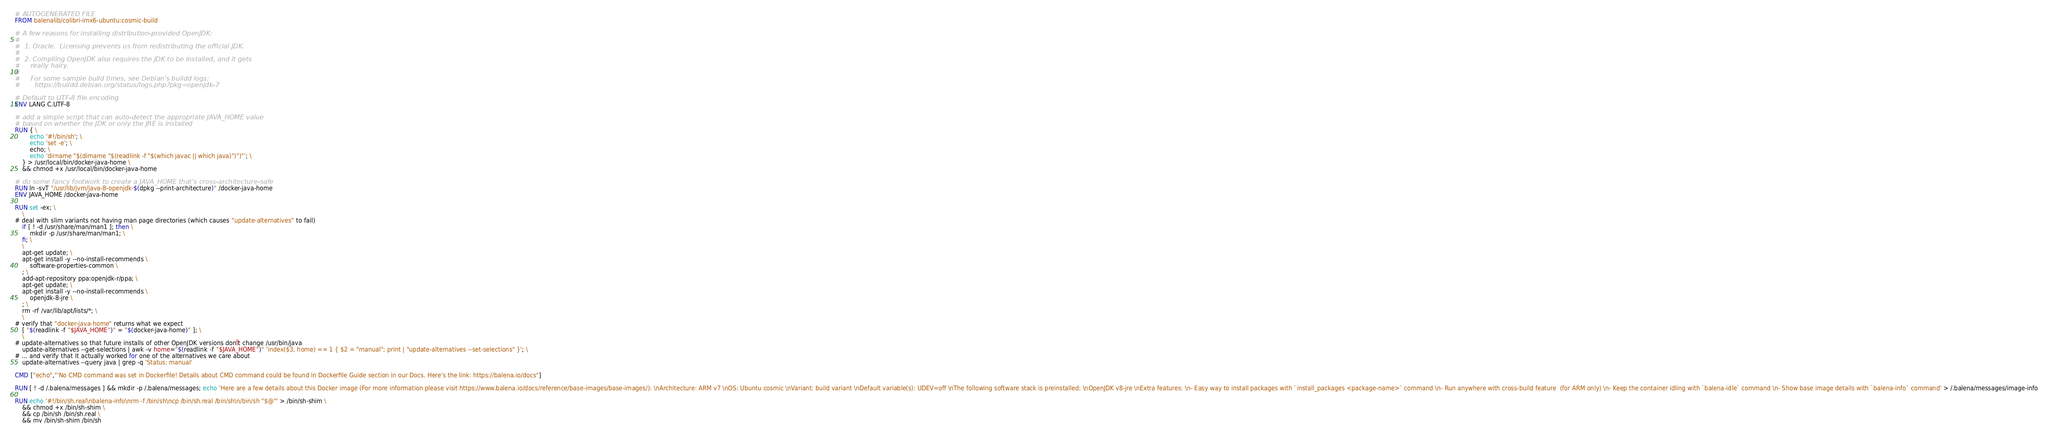<code> <loc_0><loc_0><loc_500><loc_500><_Dockerfile_># AUTOGENERATED FILE
FROM balenalib/colibri-imx6-ubuntu:cosmic-build

# A few reasons for installing distribution-provided OpenJDK:
#
#  1. Oracle.  Licensing prevents us from redistributing the official JDK.
#
#  2. Compiling OpenJDK also requires the JDK to be installed, and it gets
#     really hairy.
#
#     For some sample build times, see Debian's buildd logs:
#       https://buildd.debian.org/status/logs.php?pkg=openjdk-7

# Default to UTF-8 file.encoding
ENV LANG C.UTF-8

# add a simple script that can auto-detect the appropriate JAVA_HOME value
# based on whether the JDK or only the JRE is installed
RUN { \
		echo '#!/bin/sh'; \
		echo 'set -e'; \
		echo; \
		echo 'dirname "$(dirname "$(readlink -f "$(which javac || which java)")")"'; \
	} > /usr/local/bin/docker-java-home \
	&& chmod +x /usr/local/bin/docker-java-home

# do some fancy footwork to create a JAVA_HOME that's cross-architecture-safe
RUN ln -svT "/usr/lib/jvm/java-8-openjdk-$(dpkg --print-architecture)" /docker-java-home
ENV JAVA_HOME /docker-java-home

RUN set -ex; \
	\
# deal with slim variants not having man page directories (which causes "update-alternatives" to fail)
	if [ ! -d /usr/share/man/man1 ]; then \
		mkdir -p /usr/share/man/man1; \
	fi; \
	\
	apt-get update; \
	apt-get install -y --no-install-recommends \
		software-properties-common \
	; \
	add-apt-repository ppa:openjdk-r/ppa; \
	apt-get update; \
	apt-get install -y --no-install-recommends \
		openjdk-8-jre \
	; \
	rm -rf /var/lib/apt/lists/*; \
	\
# verify that "docker-java-home" returns what we expect
	[ "$(readlink -f "$JAVA_HOME")" = "$(docker-java-home)" ]; \
	\
# update-alternatives so that future installs of other OpenJDK versions don't change /usr/bin/java
	update-alternatives --get-selections | awk -v home="$(readlink -f "$JAVA_HOME")" 'index($3, home) == 1 { $2 = "manual"; print | "update-alternatives --set-selections" }'; \
# ... and verify that it actually worked for one of the alternatives we care about
	update-alternatives --query java | grep -q 'Status: manual'

CMD ["echo","'No CMD command was set in Dockerfile! Details about CMD command could be found in Dockerfile Guide section in our Docs. Here's the link: https://balena.io/docs"]

RUN [ ! -d /.balena/messages ] && mkdir -p /.balena/messages; echo 'Here are a few details about this Docker image (For more information please visit https://www.balena.io/docs/reference/base-images/base-images/): \nArchitecture: ARM v7 \nOS: Ubuntu cosmic \nVariant: build variant \nDefault variable(s): UDEV=off \nThe following software stack is preinstalled: \nOpenJDK v8-jre \nExtra features: \n- Easy way to install packages with `install_packages <package-name>` command \n- Run anywhere with cross-build feature  (for ARM only) \n- Keep the container idling with `balena-idle` command \n- Show base image details with `balena-info` command' > /.balena/messages/image-info

RUN echo '#!/bin/sh.real\nbalena-info\nrm -f /bin/sh\ncp /bin/sh.real /bin/sh\n/bin/sh "$@"' > /bin/sh-shim \
	&& chmod +x /bin/sh-shim \
	&& cp /bin/sh /bin/sh.real \
	&& mv /bin/sh-shim /bin/sh</code> 